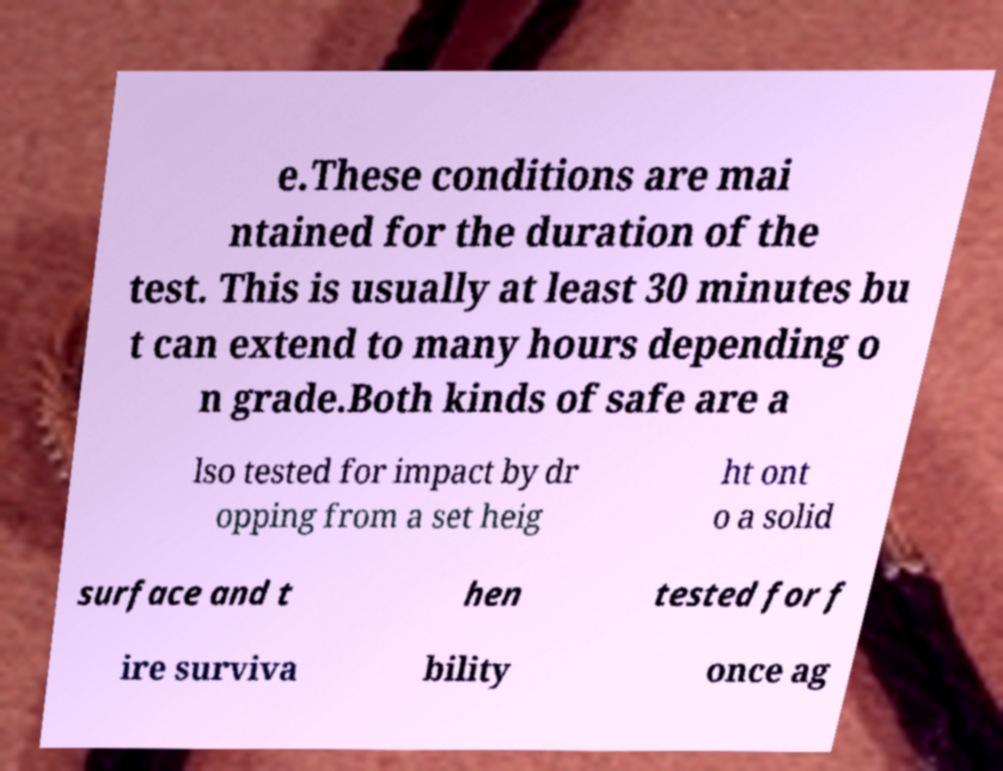Could you assist in decoding the text presented in this image and type it out clearly? e.These conditions are mai ntained for the duration of the test. This is usually at least 30 minutes bu t can extend to many hours depending o n grade.Both kinds of safe are a lso tested for impact by dr opping from a set heig ht ont o a solid surface and t hen tested for f ire surviva bility once ag 